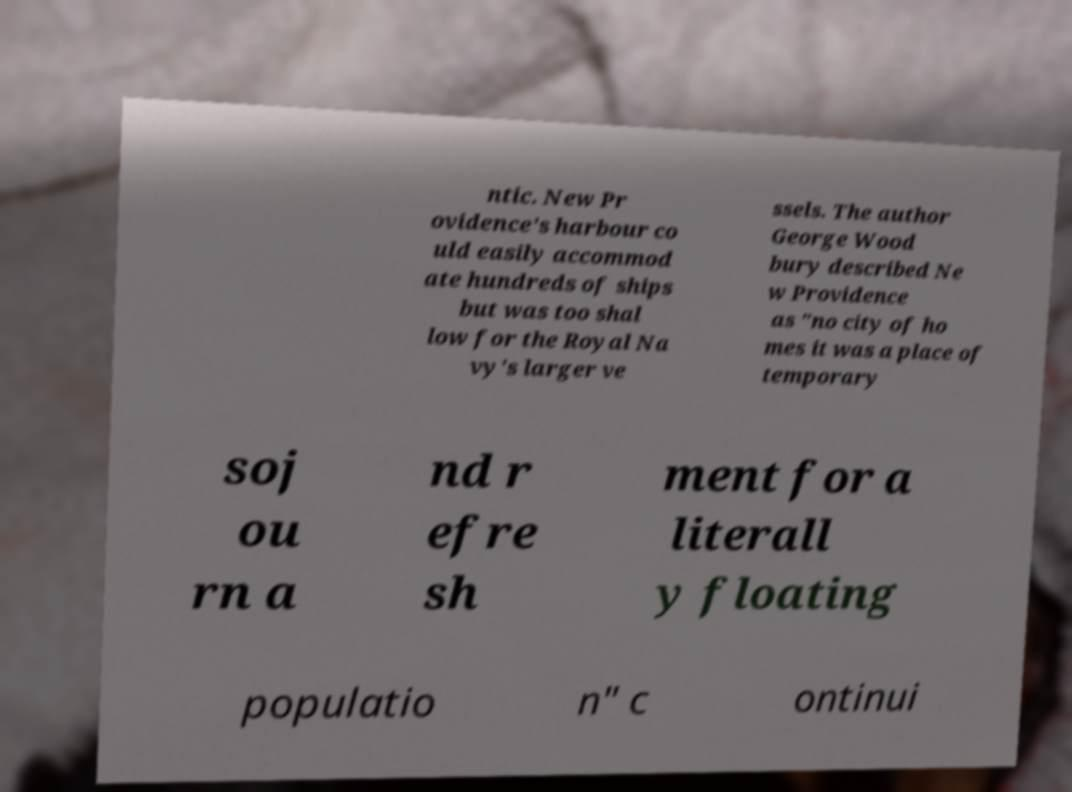I need the written content from this picture converted into text. Can you do that? ntic. New Pr ovidence's harbour co uld easily accommod ate hundreds of ships but was too shal low for the Royal Na vy's larger ve ssels. The author George Wood bury described Ne w Providence as "no city of ho mes it was a place of temporary soj ou rn a nd r efre sh ment for a literall y floating populatio n" c ontinui 